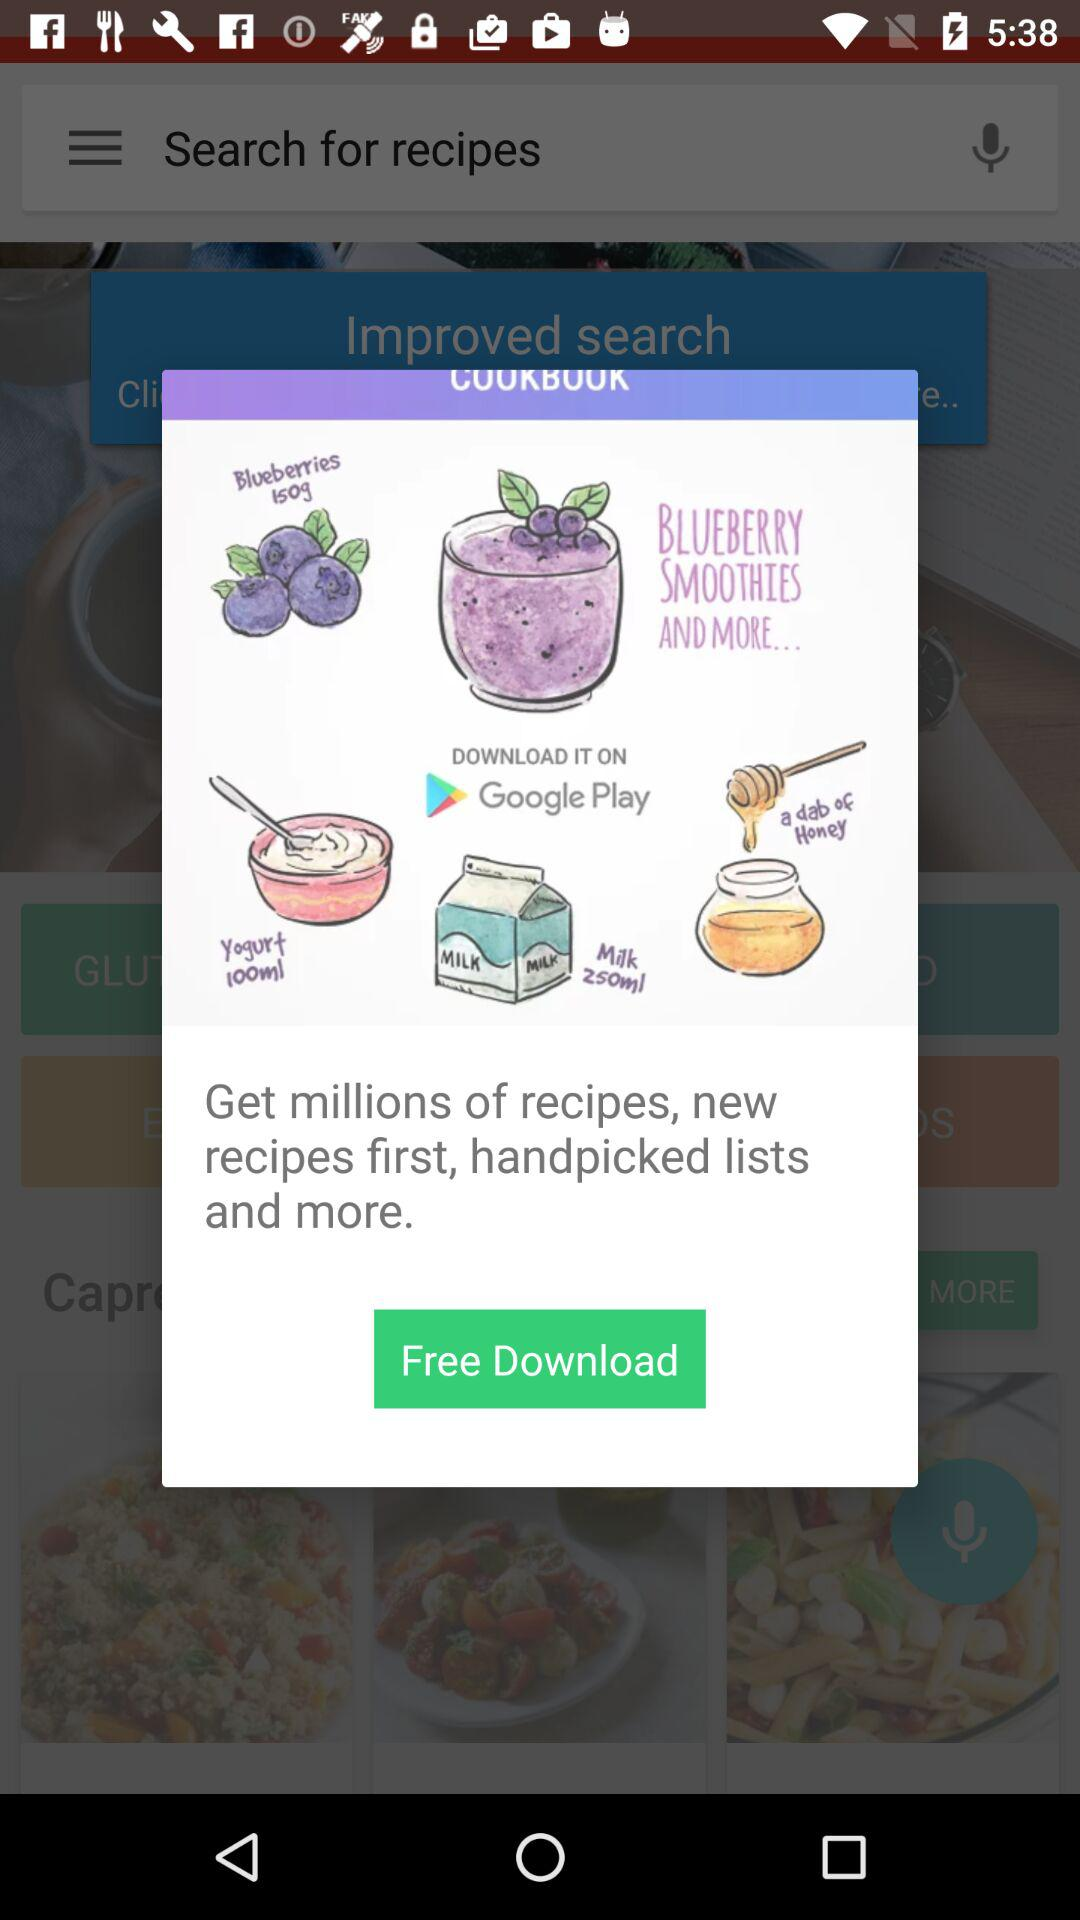What is the cost of the download? The download is free. 